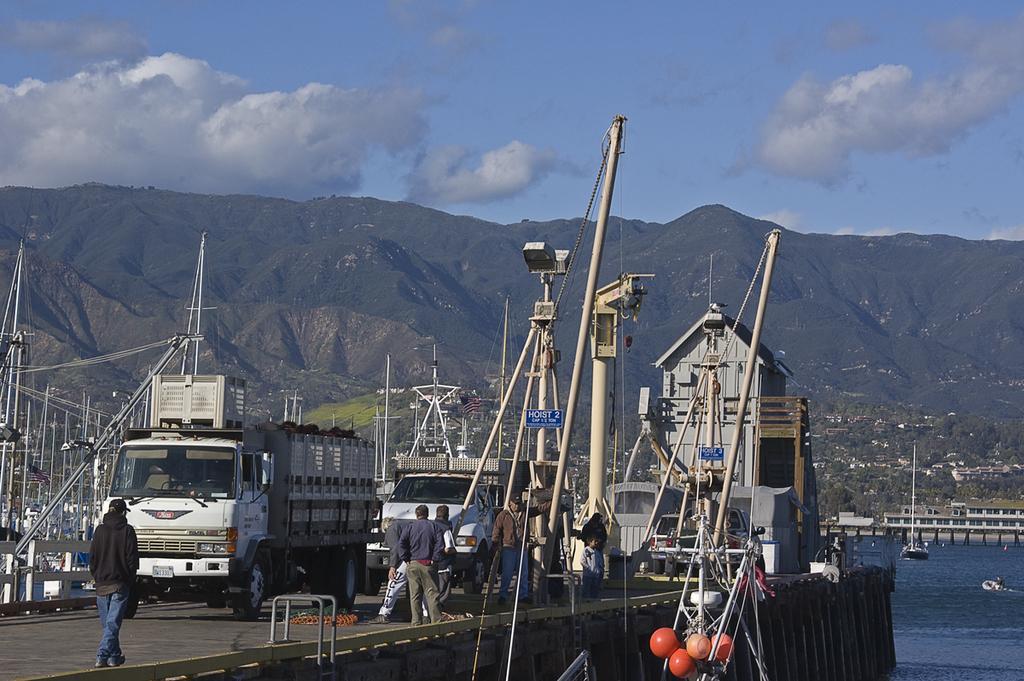In one or two sentences, can you explain what this image depicts? In this image we can see motor vehicles, poles, chains, name boards, electric lights, helmets, ropes and persons at the deck. In the background we can see hills, buildings, ships, water and sky with clouds. 